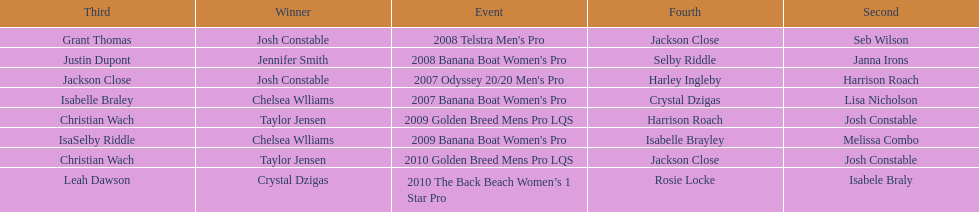At which event did taylor jensen first win? 2009 Golden Breed Mens Pro LQS. 